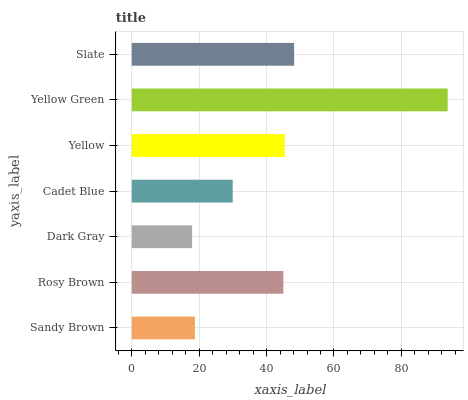Is Dark Gray the minimum?
Answer yes or no. Yes. Is Yellow Green the maximum?
Answer yes or no. Yes. Is Rosy Brown the minimum?
Answer yes or no. No. Is Rosy Brown the maximum?
Answer yes or no. No. Is Rosy Brown greater than Sandy Brown?
Answer yes or no. Yes. Is Sandy Brown less than Rosy Brown?
Answer yes or no. Yes. Is Sandy Brown greater than Rosy Brown?
Answer yes or no. No. Is Rosy Brown less than Sandy Brown?
Answer yes or no. No. Is Rosy Brown the high median?
Answer yes or no. Yes. Is Rosy Brown the low median?
Answer yes or no. Yes. Is Sandy Brown the high median?
Answer yes or no. No. Is Sandy Brown the low median?
Answer yes or no. No. 